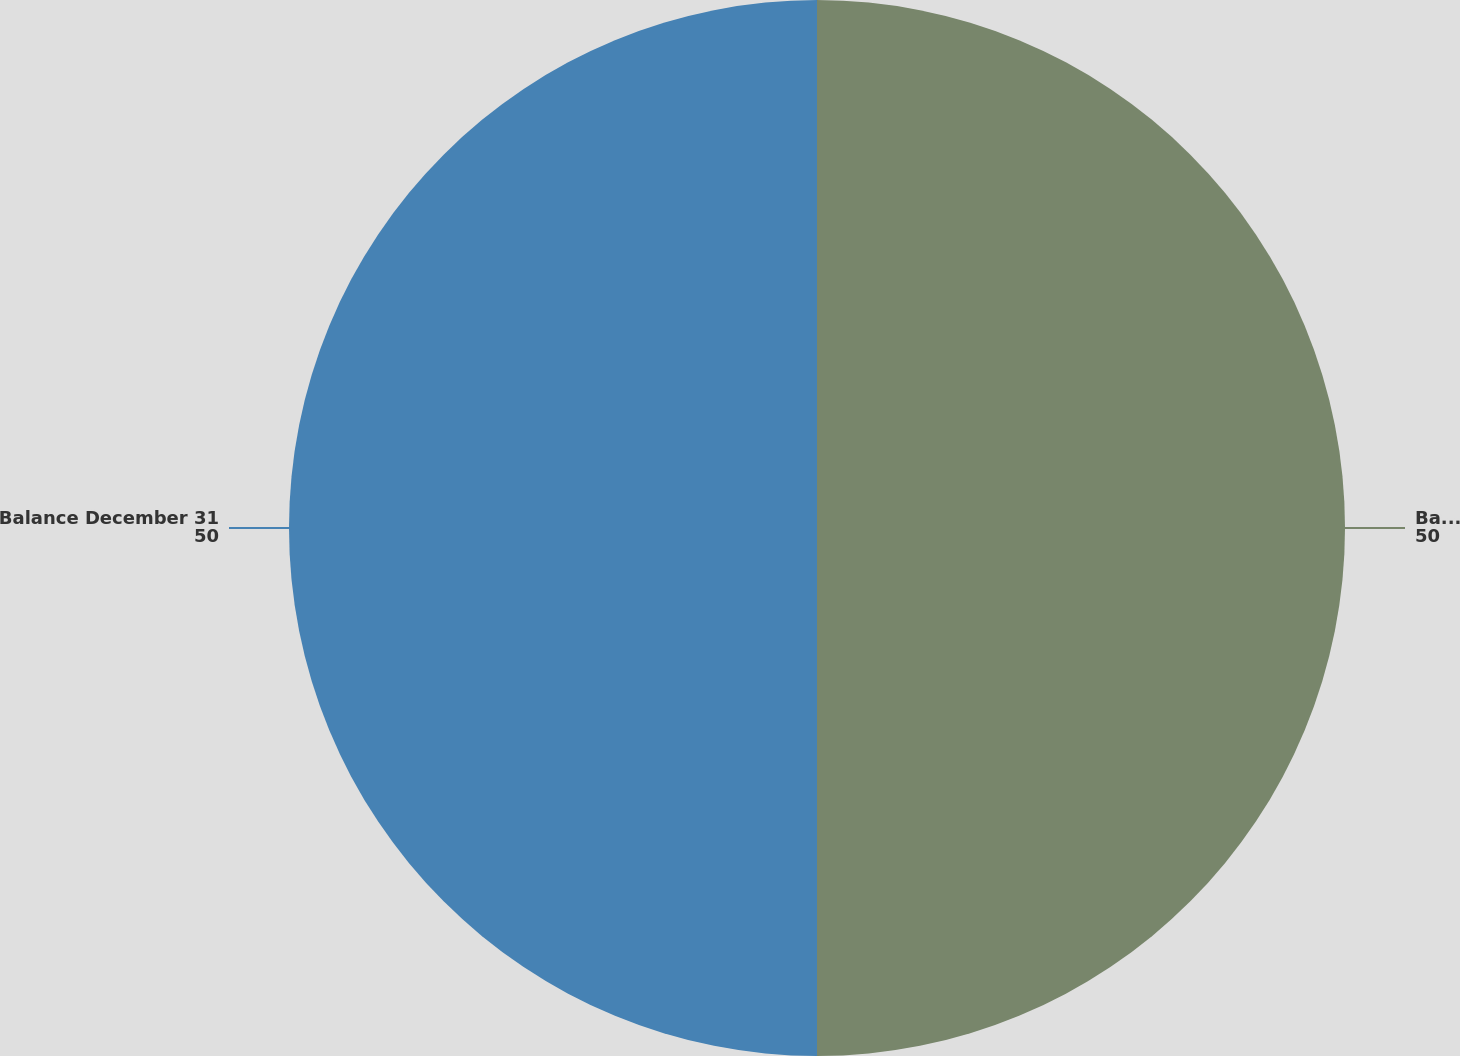Convert chart. <chart><loc_0><loc_0><loc_500><loc_500><pie_chart><fcel>Balance January 1<fcel>Balance December 31<nl><fcel>50.0%<fcel>50.0%<nl></chart> 